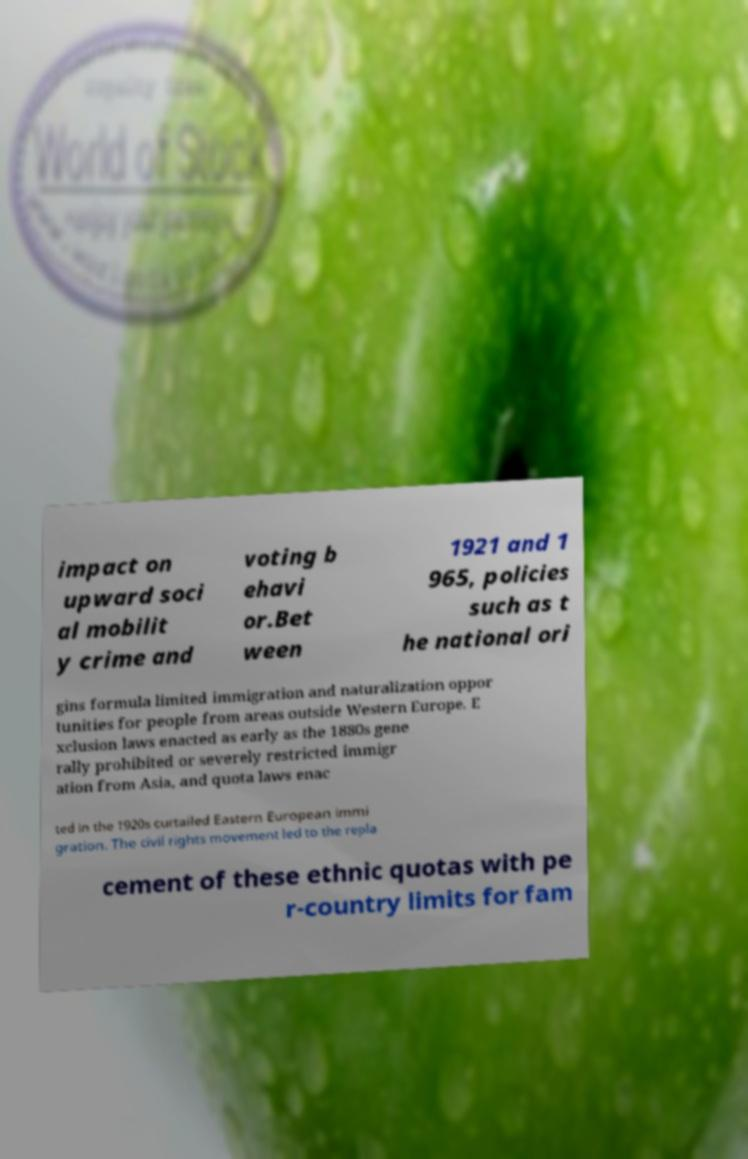Can you accurately transcribe the text from the provided image for me? impact on upward soci al mobilit y crime and voting b ehavi or.Bet ween 1921 and 1 965, policies such as t he national ori gins formula limited immigration and naturalization oppor tunities for people from areas outside Western Europe. E xclusion laws enacted as early as the 1880s gene rally prohibited or severely restricted immigr ation from Asia, and quota laws enac ted in the 1920s curtailed Eastern European immi gration. The civil rights movement led to the repla cement of these ethnic quotas with pe r-country limits for fam 